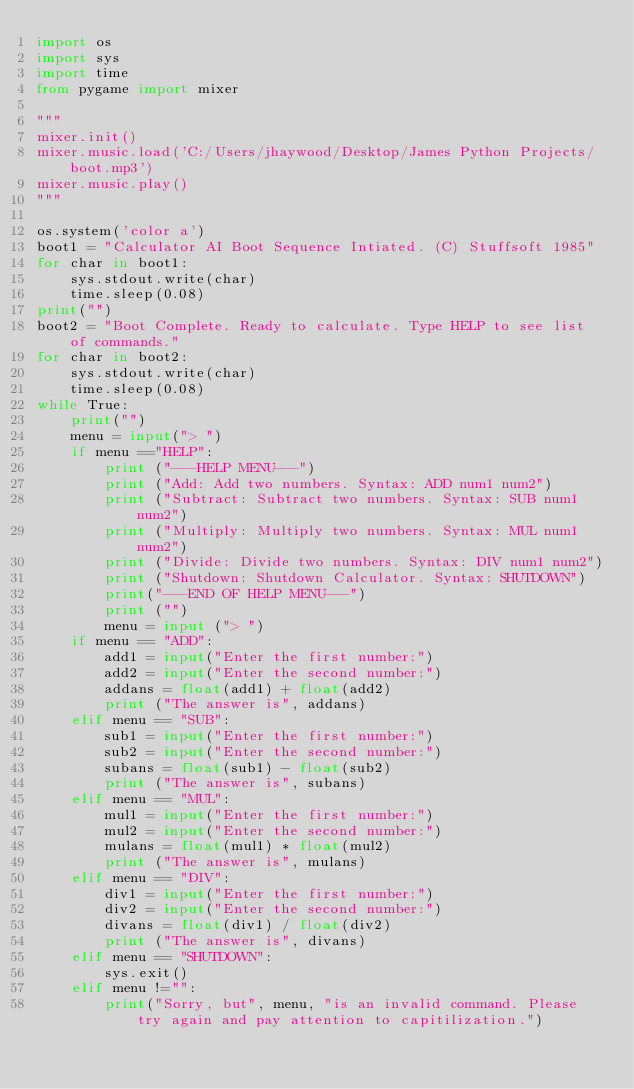<code> <loc_0><loc_0><loc_500><loc_500><_Python_>import os
import sys
import time
from pygame import mixer

"""
mixer.init()
mixer.music.load('C:/Users/jhaywood/Desktop/James Python Projects/boot.mp3')
mixer.music.play()
"""

os.system('color a') 
boot1 = "Calculator AI Boot Sequence Intiated. (C) Stuffsoft 1985"
for char in boot1:
    sys.stdout.write(char)
    time.sleep(0.08)
print("")
boot2 = "Boot Complete. Ready to calculate. Type HELP to see list of commands."
for char in boot2:
    sys.stdout.write(char)
    time.sleep(0.08)
while True:
    print("")
    menu = input("> ")
    if menu =="HELP":
        print ("---HELP MENU---")
        print ("Add: Add two numbers. Syntax: ADD num1 num2")
        print ("Subtract: Subtract two numbers. Syntax: SUB num1 num2")
        print ("Multiply: Multiply two numbers. Syntax: MUL num1 num2")
        print ("Divide: Divide two numbers. Syntax: DIV num1 num2")
        print ("Shutdown: Shutdown Calculator. Syntax: SHUTDOWN")
        print("---END OF HELP MENU---")
        print ("")
        menu = input ("> ")
    if menu == "ADD":
        add1 = input("Enter the first number:")
        add2 = input("Enter the second number:")
        addans = float(add1) + float(add2)
        print ("The answer is", addans)
    elif menu == "SUB":
        sub1 = input("Enter the first number:")
        sub2 = input("Enter the second number:")
        subans = float(sub1) - float(sub2)
        print ("The answer is", subans)
    elif menu == "MUL":
        mul1 = input("Enter the first number:")
        mul2 = input("Enter the second number:")
        mulans = float(mul1) * float(mul2)
        print ("The answer is", mulans)
    elif menu == "DIV":
        div1 = input("Enter the first number:")
        div2 = input("Enter the second number:")
        divans = float(div1) / float(div2)
        print ("The answer is", divans)
    elif menu == "SHUTDOWN":
        sys.exit()
    elif menu !="":
        print("Sorry, but", menu, "is an invalid command. Please try again and pay attention to capitilization.")
        
        
    
</code> 